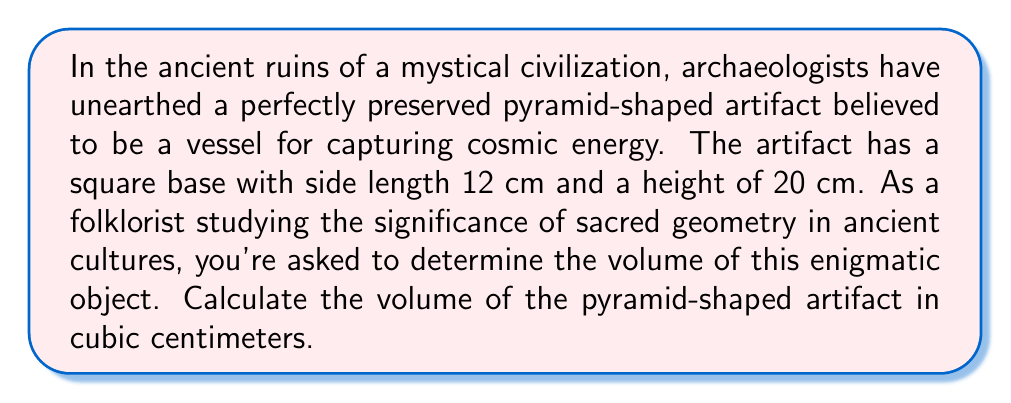Solve this math problem. To find the volume of a pyramid, we use the formula:

$$V = \frac{1}{3} \times B \times h$$

Where:
$V$ = Volume
$B$ = Area of the base
$h$ = Height of the pyramid

Steps:
1. Calculate the area of the square base:
   $B = s^2 = 12 \text{ cm} \times 12 \text{ cm} = 144 \text{ cm}^2$

2. Apply the volume formula:
   $$V = \frac{1}{3} \times 144 \text{ cm}^2 \times 20 \text{ cm}$$

3. Simplify:
   $$V = \frac{144 \times 20}{3} \text{ cm}^3 = 960 \text{ cm}^3$$

[asy]
import three;

size(200);
currentprojection=perspective(6,3,2);

triple A=(0,0,0), B=(2,0,0), C=(2,2,0), D=(0,2,0), E=(1,1,3);

draw(A--B--C--D--cycle);
draw(A--E--C,dashed);
draw(B--E--D);

label("12 cm",0.5(A--B),S);
label("12 cm",0.5(B--C),E);
label("20 cm",0.5(A--E),NW);

[/asy]
Answer: 960 cm³ 